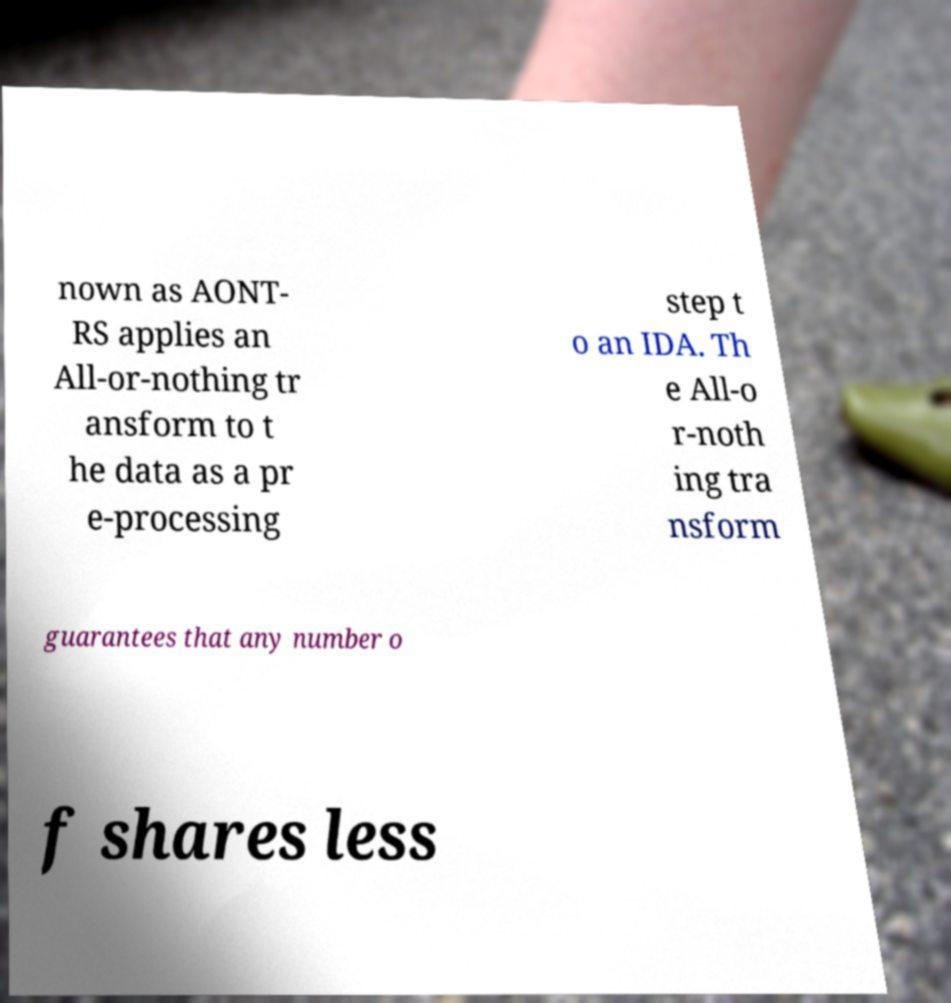Can you read and provide the text displayed in the image?This photo seems to have some interesting text. Can you extract and type it out for me? nown as AONT- RS applies an All-or-nothing tr ansform to t he data as a pr e-processing step t o an IDA. Th e All-o r-noth ing tra nsform guarantees that any number o f shares less 